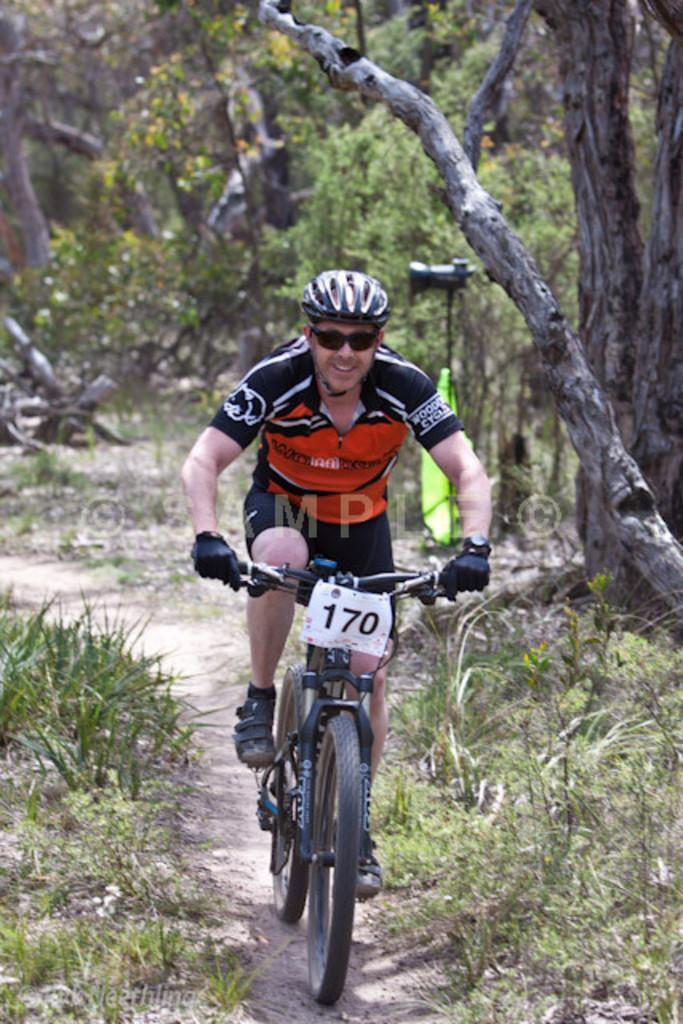What is the main subject in the center of the image? There is a boy in the center of the image. What is the boy doing in the image? The boy is on a bicycle. What type of vegetation can be seen at the bottom side of the image? There are plants at the bottom side of the image. What can be seen in the background of the image? There are trees in the background of the image. What type of celery can be seen growing in the background of the image? There is no celery present in the image; it features a boy on a bicycle with plants at the bottom side and trees in the background. 